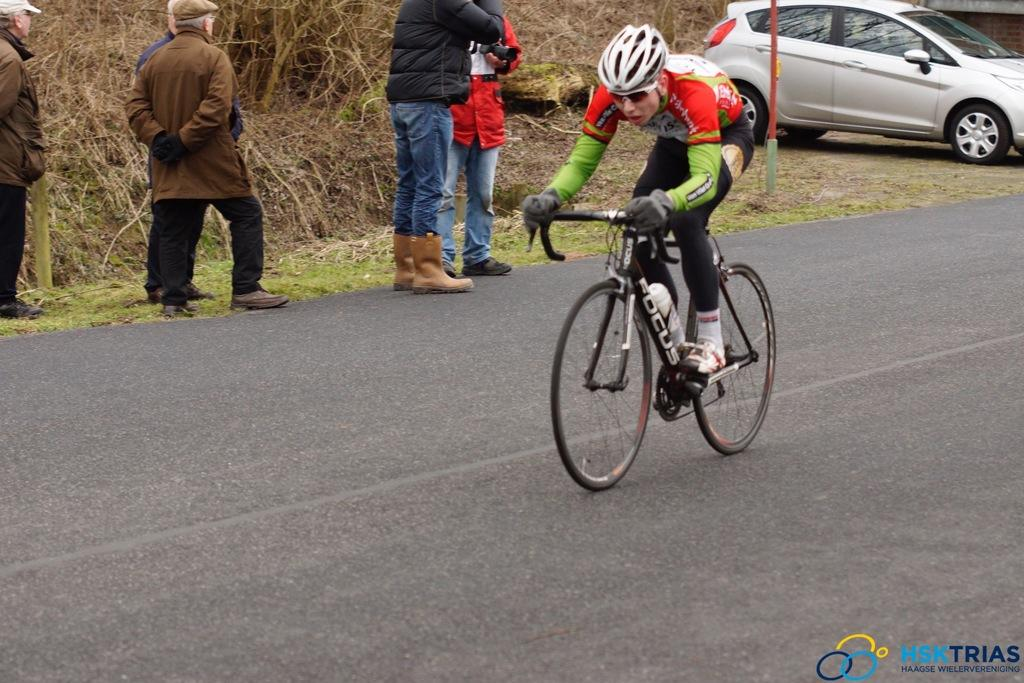What is the person in the image wearing on their head? The person in the image is wearing a helmet. What activity is the person with the helmet engaged in? The person is riding a bicycle. Are there any other people present in the image? Yes, there are people beside the person riding the bicycle. What type of vehicle can be seen in the image? There is a car in the image. What type of yoke is the person using to steer the bicycle in the image? There is no yoke present in the image; the person is using handlebars to steer the bicycle. 